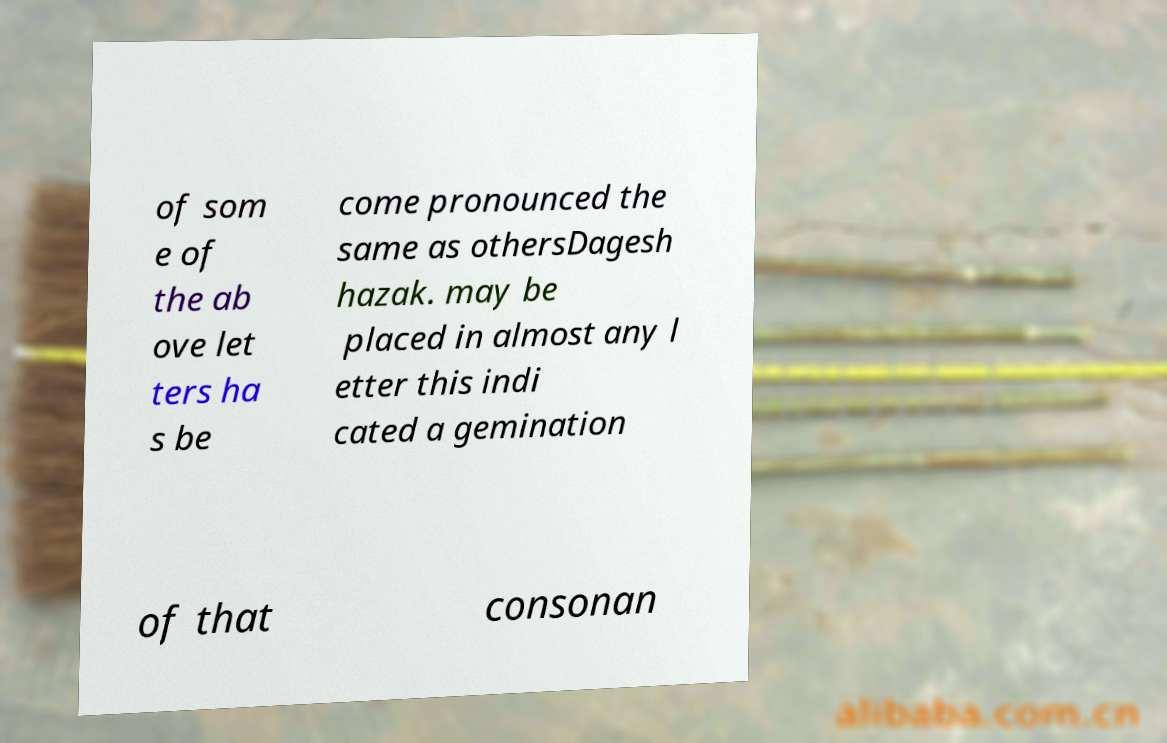Can you accurately transcribe the text from the provided image for me? of som e of the ab ove let ters ha s be come pronounced the same as othersDagesh hazak. may be placed in almost any l etter this indi cated a gemination of that consonan 